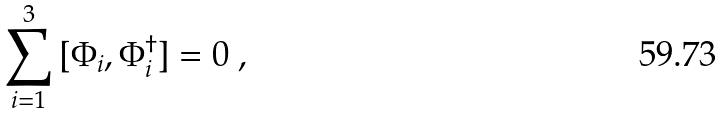Convert formula to latex. <formula><loc_0><loc_0><loc_500><loc_500>\sum _ { i = 1 } ^ { 3 } \, [ \Phi _ { i } , \Phi _ { i } ^ { \dagger } ] = 0 \ ,</formula> 